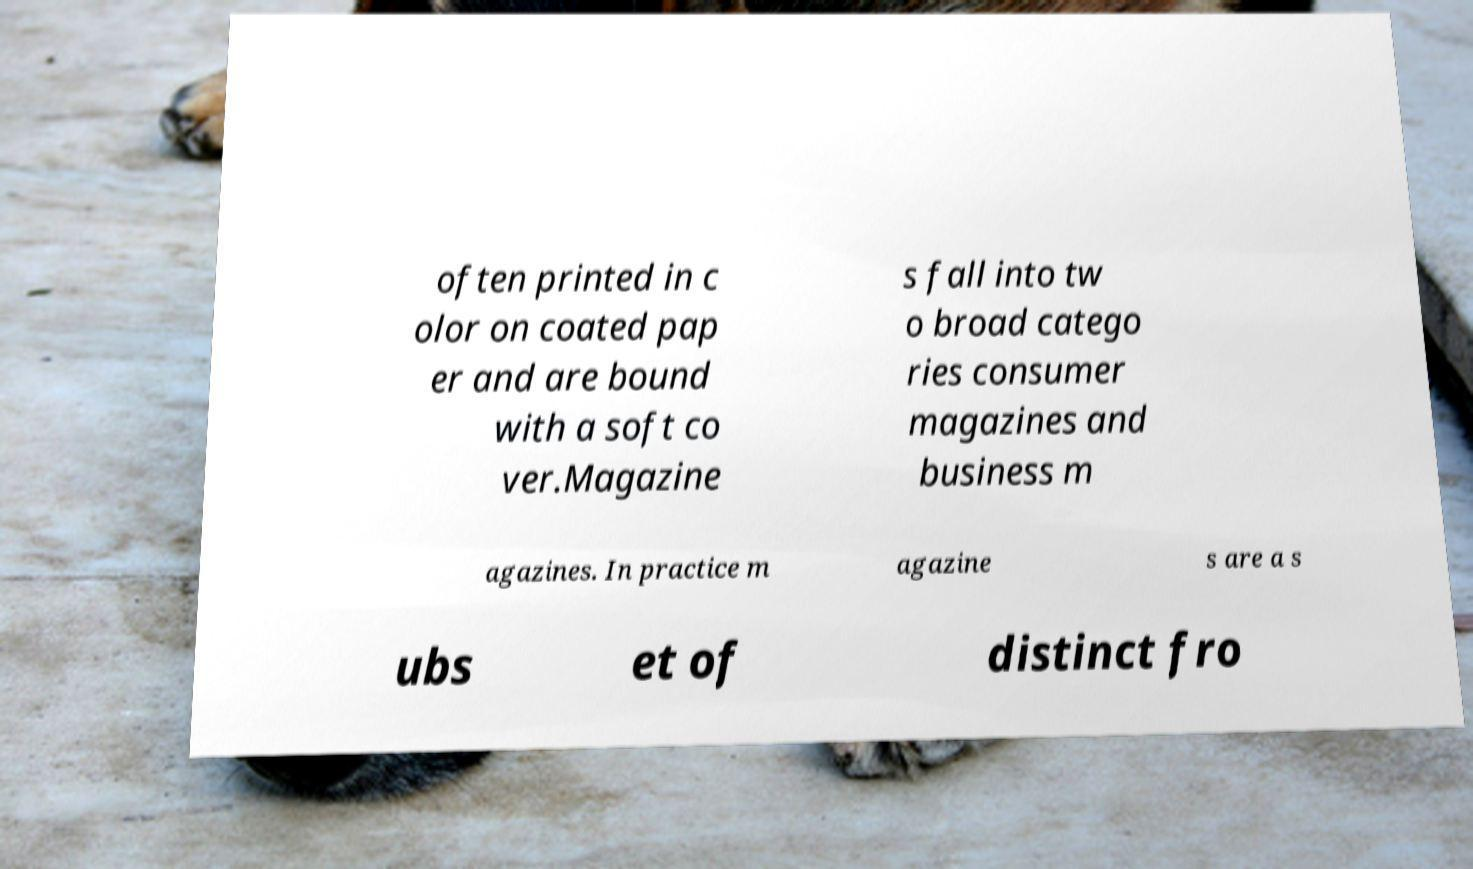Could you assist in decoding the text presented in this image and type it out clearly? often printed in c olor on coated pap er and are bound with a soft co ver.Magazine s fall into tw o broad catego ries consumer magazines and business m agazines. In practice m agazine s are a s ubs et of distinct fro 